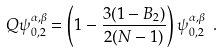<formula> <loc_0><loc_0><loc_500><loc_500>Q \psi _ { 0 , 2 } ^ { \alpha , \beta } = \left ( 1 - \frac { 3 ( 1 - B _ { 2 } ) } { 2 ( N - 1 ) } \right ) \psi _ { 0 , 2 } ^ { \alpha , \beta } \ .</formula> 